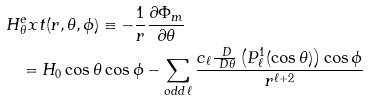Convert formula to latex. <formula><loc_0><loc_0><loc_500><loc_500>H & _ { \theta } ^ { e } x t ( r , \theta , \phi ) \equiv - \frac { 1 } { r } \frac { \partial \Phi _ { m } } { \partial \theta } \\ & = H _ { 0 } \cos \theta \cos \phi - \sum _ { o d d \, \ell } \frac { c _ { \ell } \frac { \ D } { \ D \theta } \left ( P _ { \ell } ^ { 1 } ( \cos \theta ) \right ) \cos \phi } { r ^ { \ell + 2 } }</formula> 